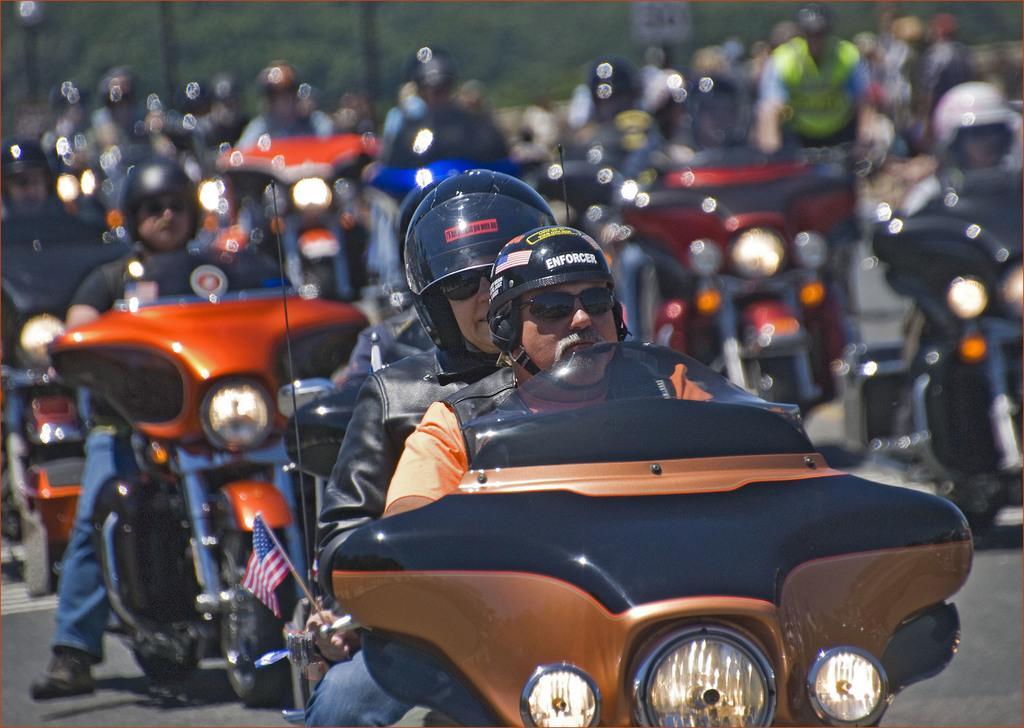Describe this image in one or two sentences. In this image we can see a group of people wearing helmets are riding motorcycles placed on the ground. In the foreground we can see a flag. In the background, we can see a group of poles and trees. 